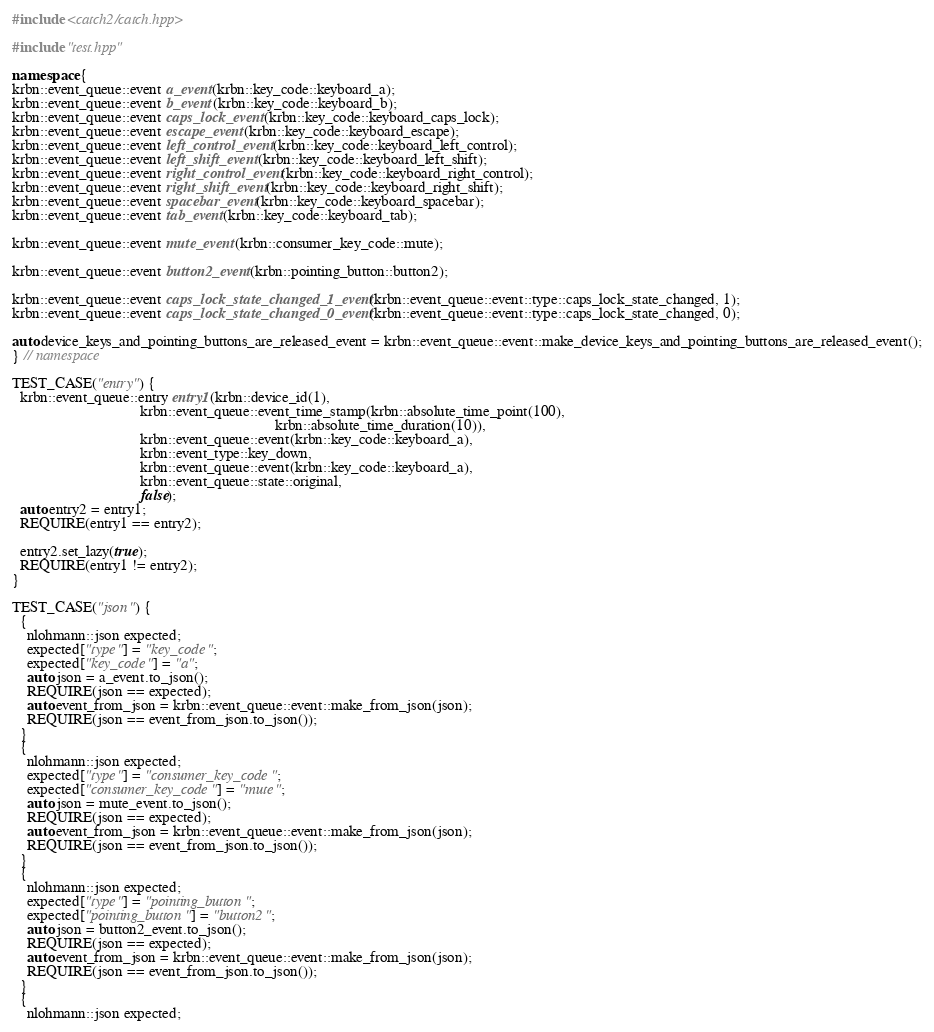Convert code to text. <code><loc_0><loc_0><loc_500><loc_500><_C++_>#include <catch2/catch.hpp>

#include "test.hpp"

namespace {
krbn::event_queue::event a_event(krbn::key_code::keyboard_a);
krbn::event_queue::event b_event(krbn::key_code::keyboard_b);
krbn::event_queue::event caps_lock_event(krbn::key_code::keyboard_caps_lock);
krbn::event_queue::event escape_event(krbn::key_code::keyboard_escape);
krbn::event_queue::event left_control_event(krbn::key_code::keyboard_left_control);
krbn::event_queue::event left_shift_event(krbn::key_code::keyboard_left_shift);
krbn::event_queue::event right_control_event(krbn::key_code::keyboard_right_control);
krbn::event_queue::event right_shift_event(krbn::key_code::keyboard_right_shift);
krbn::event_queue::event spacebar_event(krbn::key_code::keyboard_spacebar);
krbn::event_queue::event tab_event(krbn::key_code::keyboard_tab);

krbn::event_queue::event mute_event(krbn::consumer_key_code::mute);

krbn::event_queue::event button2_event(krbn::pointing_button::button2);

krbn::event_queue::event caps_lock_state_changed_1_event(krbn::event_queue::event::type::caps_lock_state_changed, 1);
krbn::event_queue::event caps_lock_state_changed_0_event(krbn::event_queue::event::type::caps_lock_state_changed, 0);

auto device_keys_and_pointing_buttons_are_released_event = krbn::event_queue::event::make_device_keys_and_pointing_buttons_are_released_event();
} // namespace

TEST_CASE("entry") {
  krbn::event_queue::entry entry1(krbn::device_id(1),
                                  krbn::event_queue::event_time_stamp(krbn::absolute_time_point(100),
                                                                      krbn::absolute_time_duration(10)),
                                  krbn::event_queue::event(krbn::key_code::keyboard_a),
                                  krbn::event_type::key_down,
                                  krbn::event_queue::event(krbn::key_code::keyboard_a),
                                  krbn::event_queue::state::original,
                                  false);
  auto entry2 = entry1;
  REQUIRE(entry1 == entry2);

  entry2.set_lazy(true);
  REQUIRE(entry1 != entry2);
}

TEST_CASE("json") {
  {
    nlohmann::json expected;
    expected["type"] = "key_code";
    expected["key_code"] = "a";
    auto json = a_event.to_json();
    REQUIRE(json == expected);
    auto event_from_json = krbn::event_queue::event::make_from_json(json);
    REQUIRE(json == event_from_json.to_json());
  }
  {
    nlohmann::json expected;
    expected["type"] = "consumer_key_code";
    expected["consumer_key_code"] = "mute";
    auto json = mute_event.to_json();
    REQUIRE(json == expected);
    auto event_from_json = krbn::event_queue::event::make_from_json(json);
    REQUIRE(json == event_from_json.to_json());
  }
  {
    nlohmann::json expected;
    expected["type"] = "pointing_button";
    expected["pointing_button"] = "button2";
    auto json = button2_event.to_json();
    REQUIRE(json == expected);
    auto event_from_json = krbn::event_queue::event::make_from_json(json);
    REQUIRE(json == event_from_json.to_json());
  }
  {
    nlohmann::json expected;</code> 